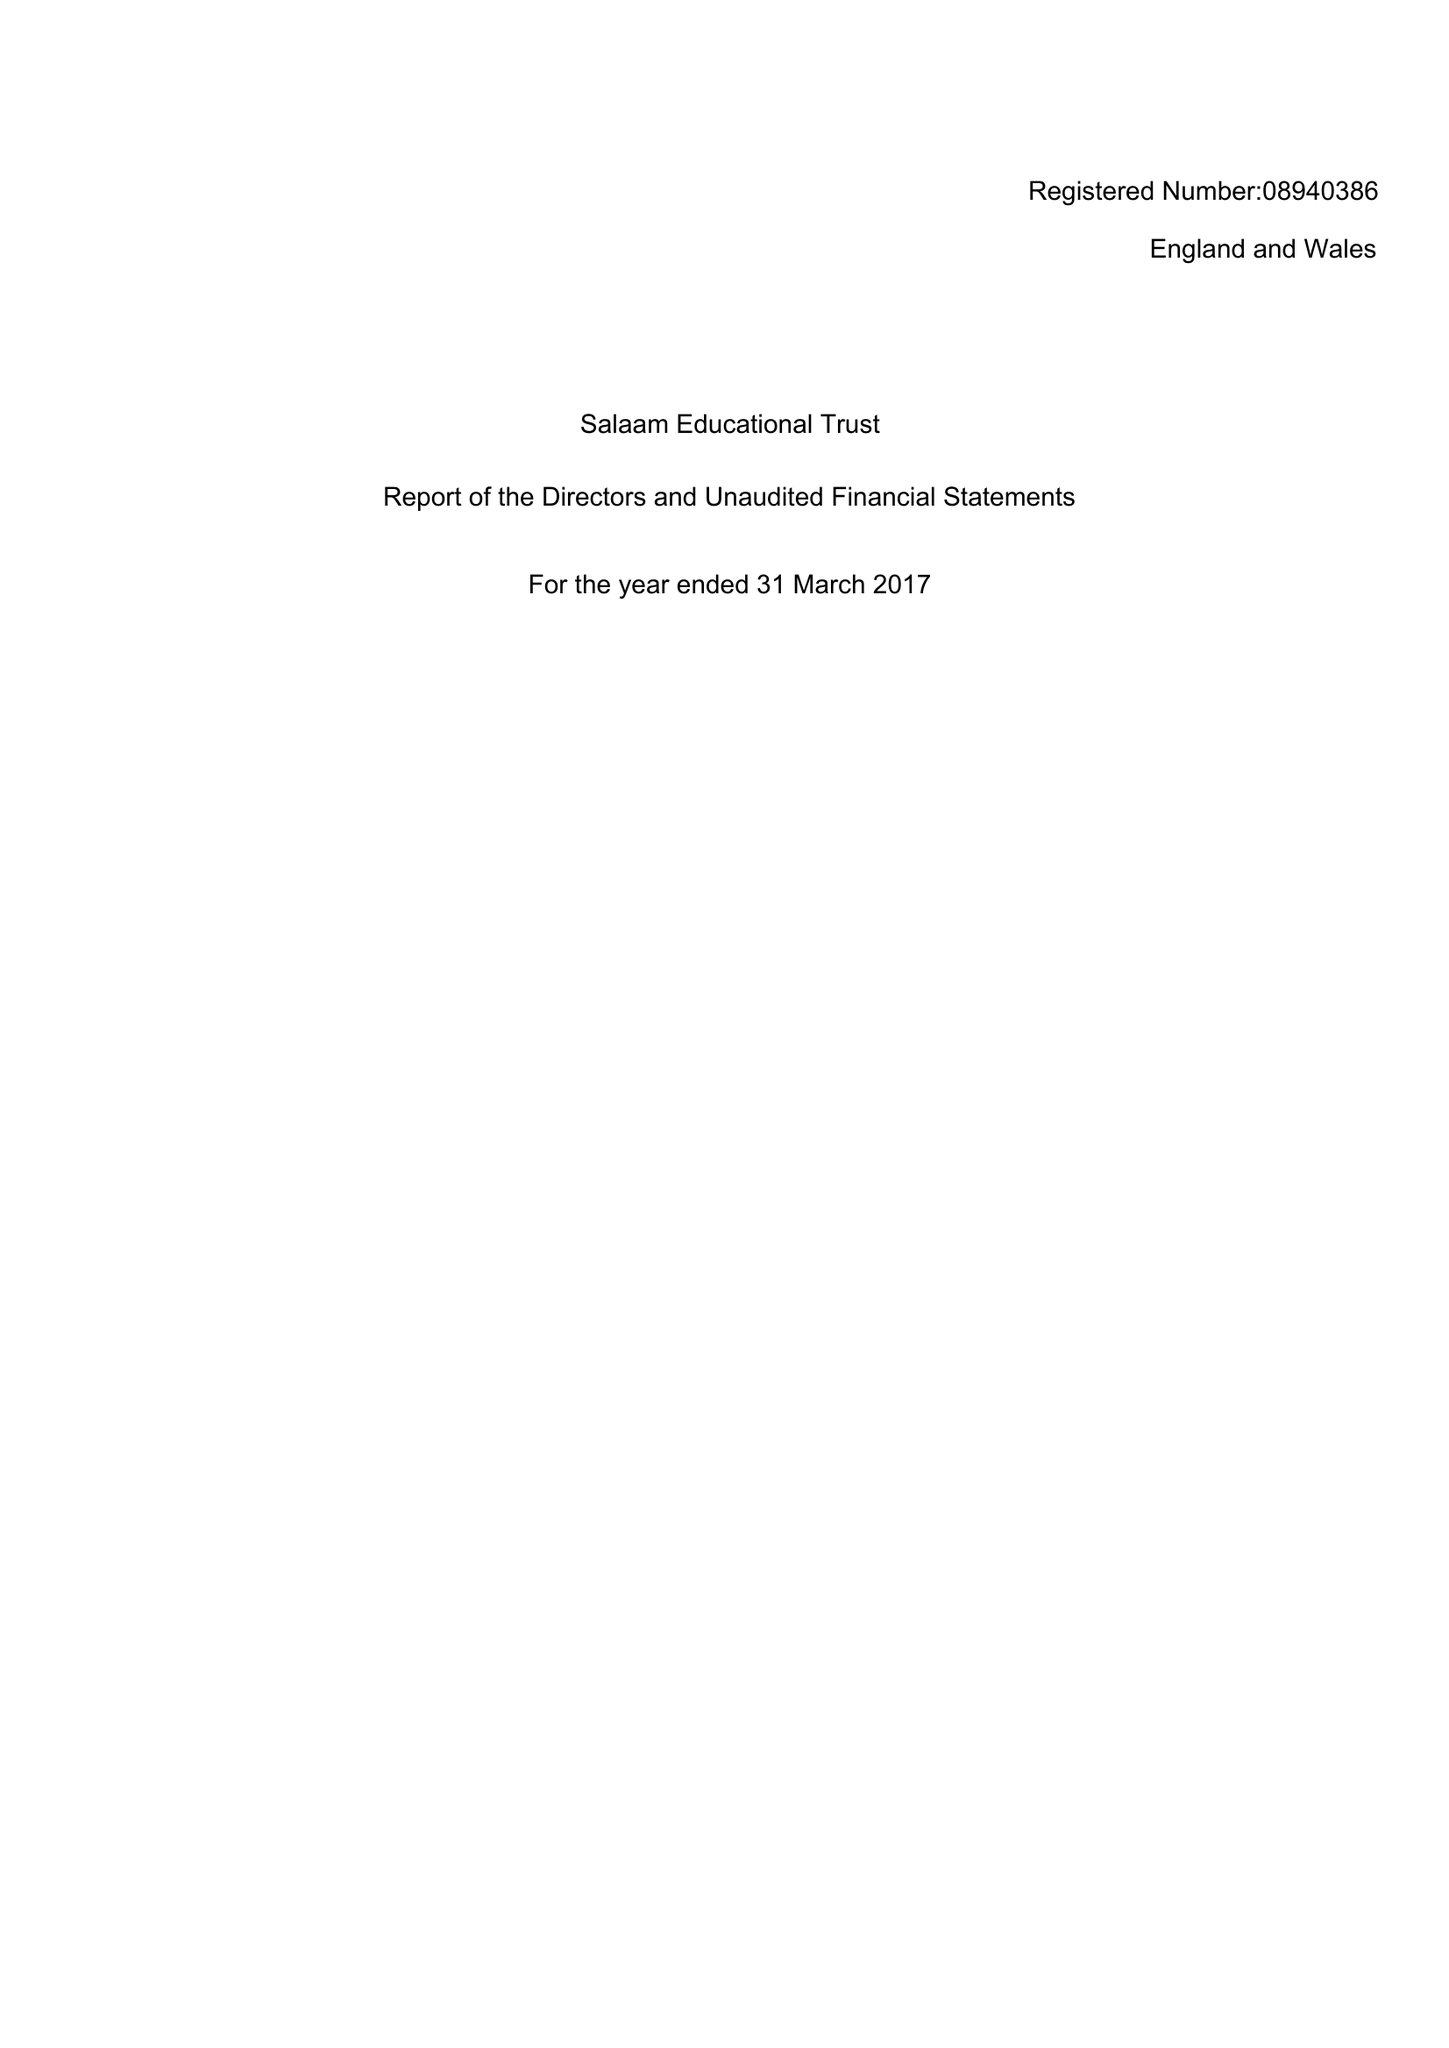What is the value for the report_date?
Answer the question using a single word or phrase. 2017-03-31 